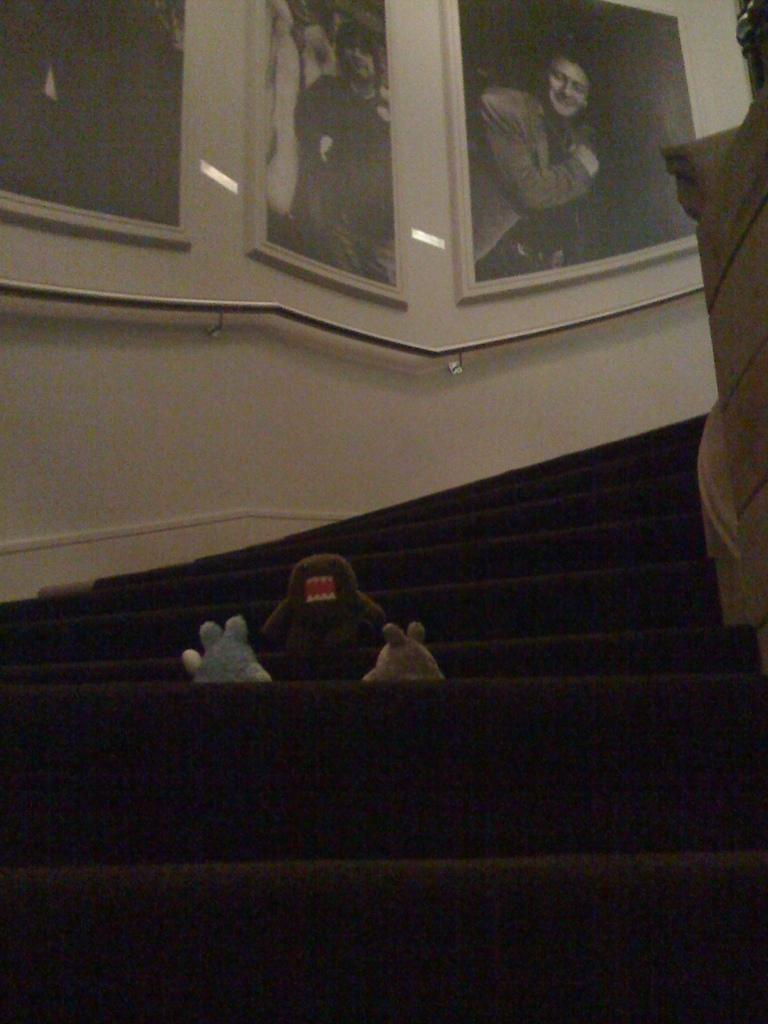What can be seen in the image that people use to move between different levels? There are stairs in the image. What objects are on the stairs in the image? There are toys on the stairs. What can be seen on the wall in the background of the image? There are photo frames attached to the wall in the background of the image. What type of hearing aid is visible on the stairs in the image? There is no hearing aid present in the image; it features stairs with toys on them. What emotion is the person feeling in the image, as indicated by their body language or facial expression? There is no person present in the image, so it is impossible to determine their emotions or body language. 